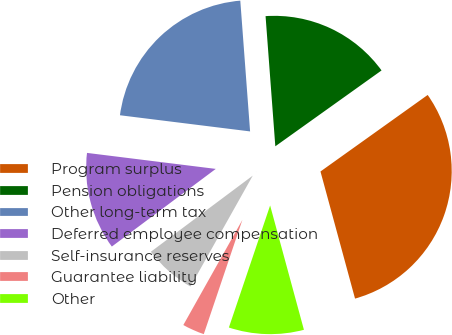<chart> <loc_0><loc_0><loc_500><loc_500><pie_chart><fcel>Program surplus<fcel>Pension obligations<fcel>Other long-term tax<fcel>Deferred employee compensation<fcel>Self-insurance reserves<fcel>Guarantee liability<fcel>Other<nl><fcel>30.64%<fcel>16.32%<fcel>21.84%<fcel>12.18%<fcel>6.64%<fcel>2.96%<fcel>9.41%<nl></chart> 